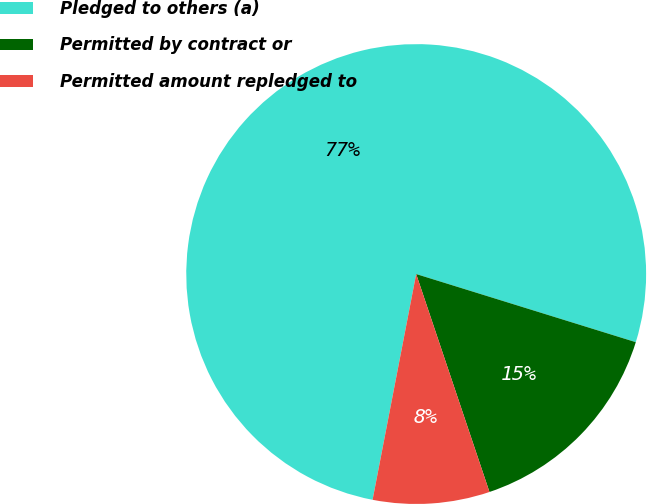<chart> <loc_0><loc_0><loc_500><loc_500><pie_chart><fcel>Pledged to others (a)<fcel>Permitted by contract or<fcel>Permitted amount repledged to<nl><fcel>76.75%<fcel>15.05%<fcel>8.2%<nl></chart> 